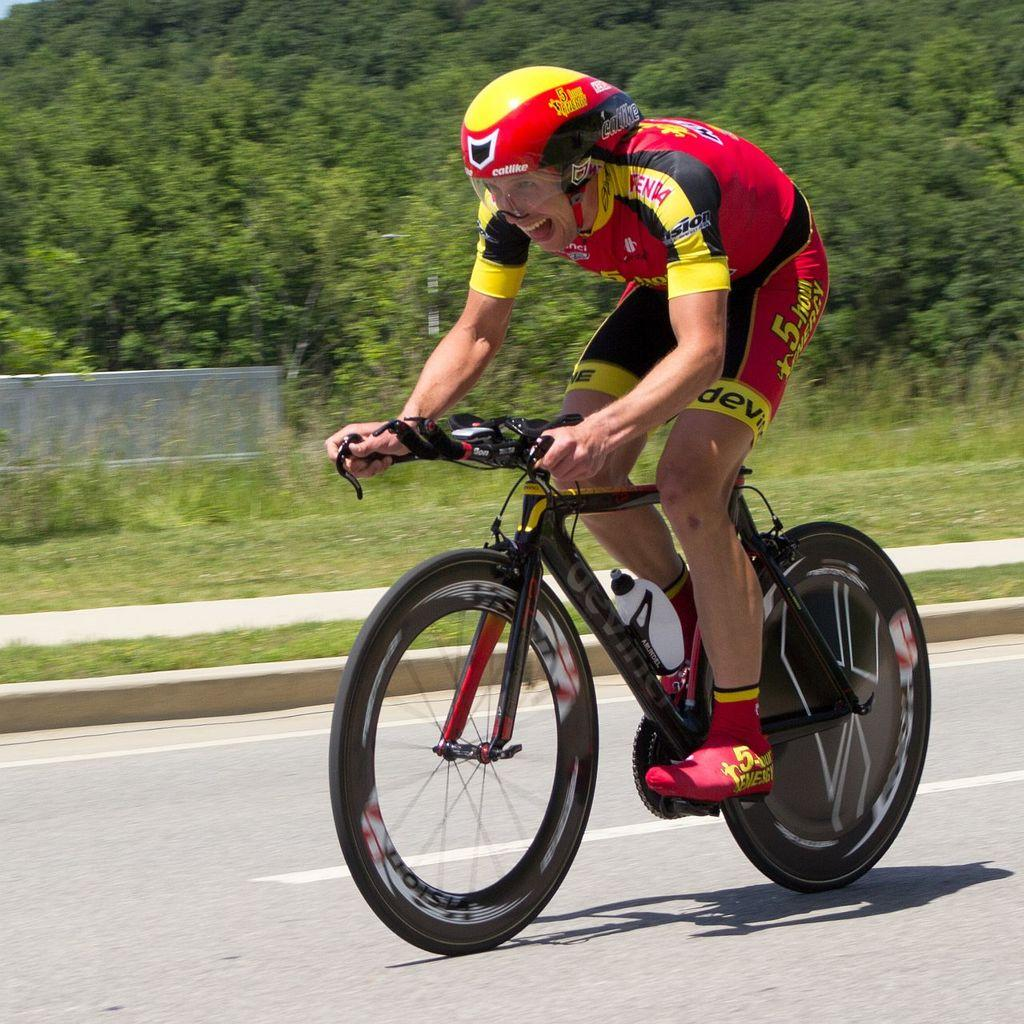What is the main subject of the image? There is a person in the image. What is the person doing in the image? The person is riding a bicycle. What type of natural environment can be seen in the image? There are trees and grass in the image. How does the person tie a knot while riding the bicycle in the image? There is no indication in the image that the person is tying a knot while riding the bicycle. 